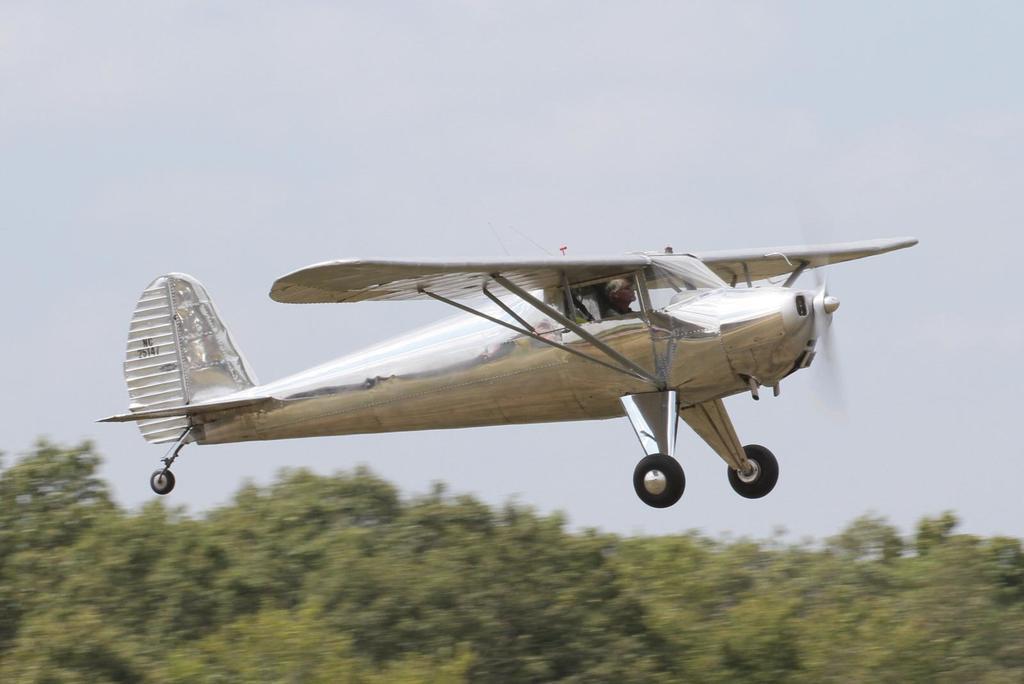Could you give a brief overview of what you see in this image? In this image there is an airplane flying in the air. A person is in the airplane. Bottom of the image there are trees. Top of the image there is sky. 